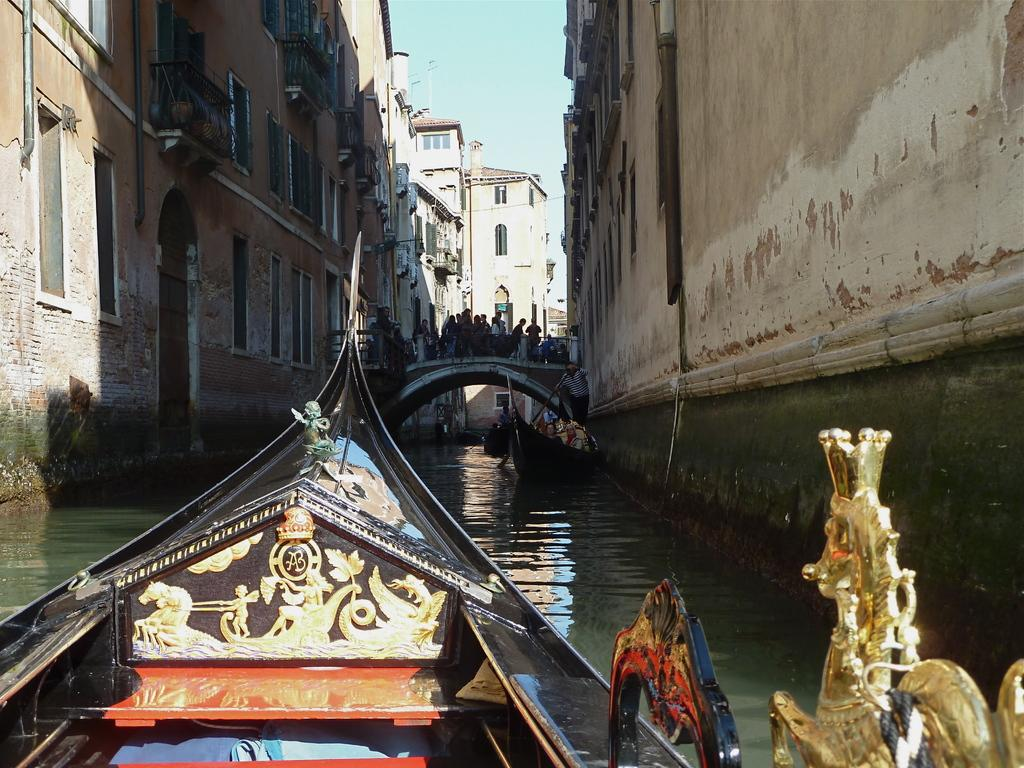What is on the water in the image? There are boats on the water in the image. Can you describe the people in the image? There is a group of people visible in the image. What structures can be seen in the image? There are buildings visible in the image. What is visible in the background of the image? The sky is visible in the background of the image. What type of breakfast is being served on the boats in the image? There is no breakfast visible in the image; it features boats on the water, a group of people, buildings, and the sky. How many steps are required to reach the top of the tallest building in the image? There is no information provided about the height or number of steps in the buildings, and therefore this question cannot be answered definitively. 